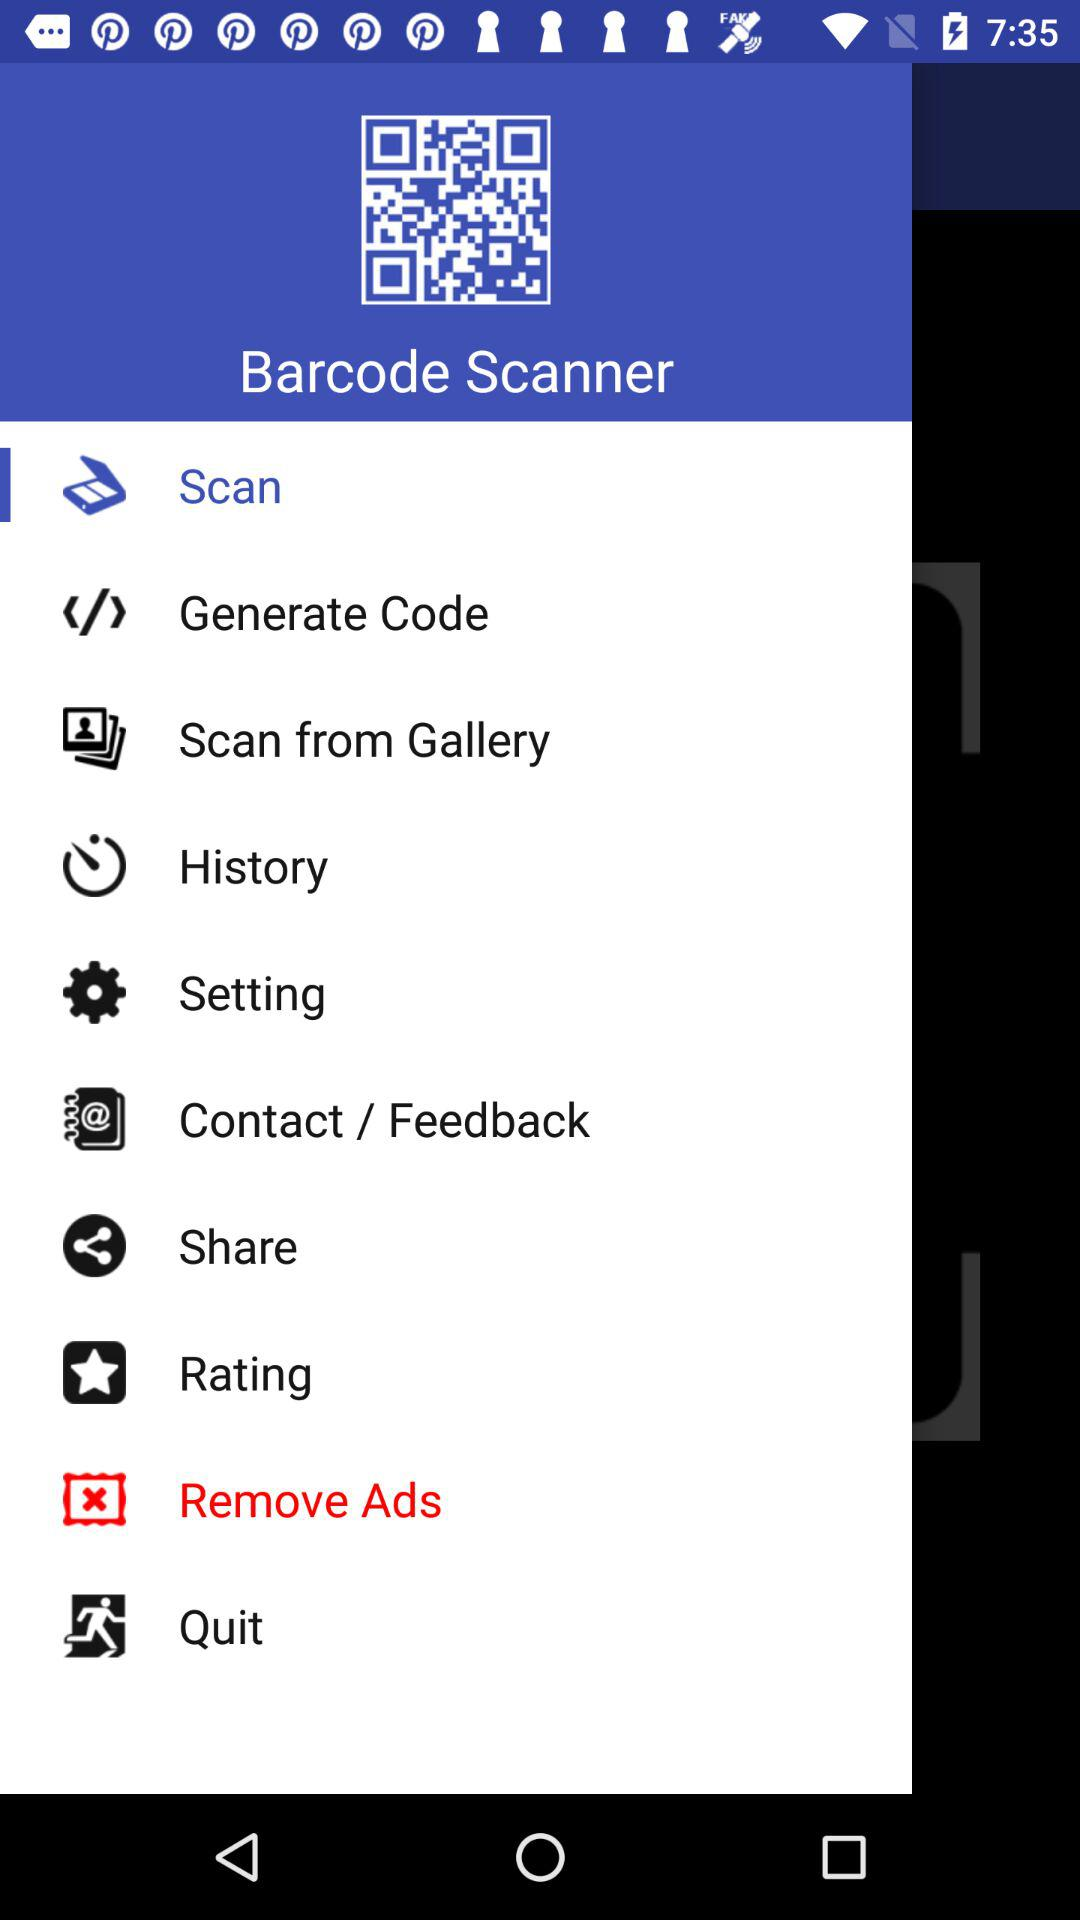What is the selected option? The selected option is "Remove Ads". 